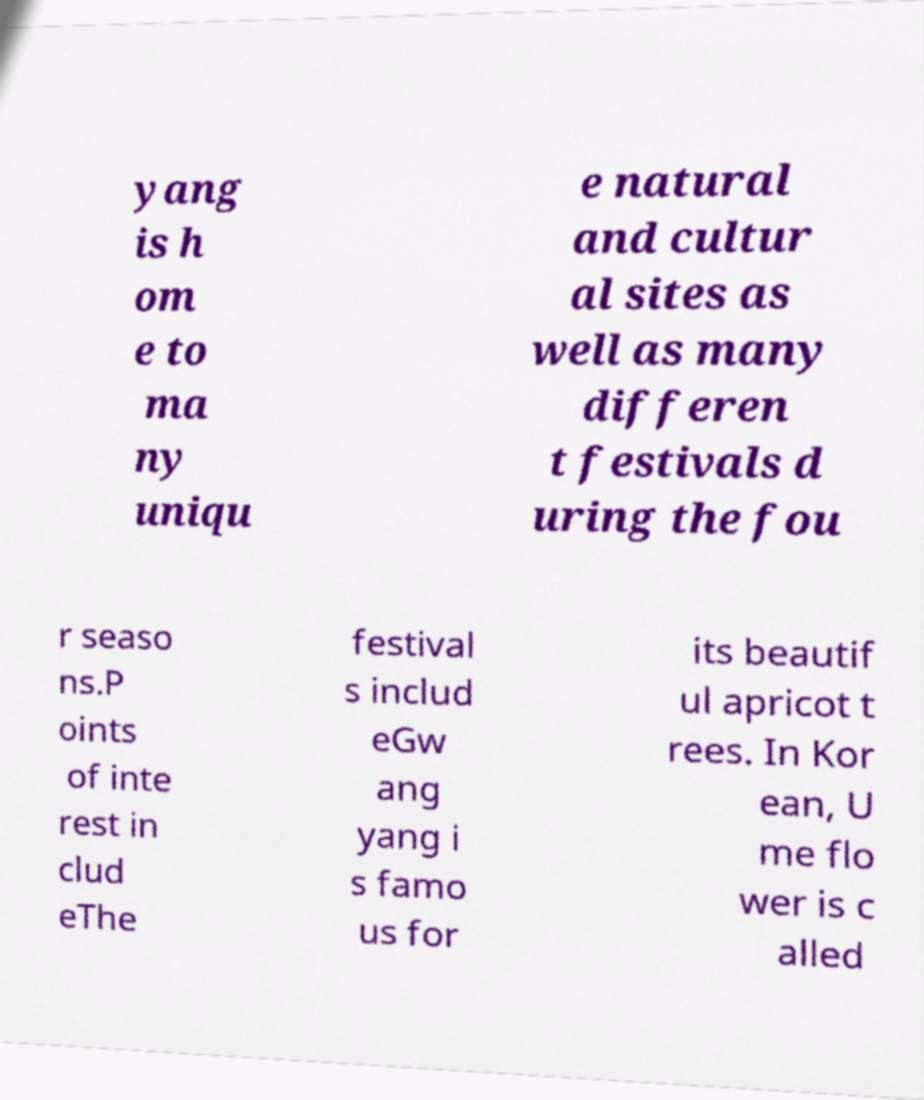Please read and relay the text visible in this image. What does it say? yang is h om e to ma ny uniqu e natural and cultur al sites as well as many differen t festivals d uring the fou r seaso ns.P oints of inte rest in clud eThe festival s includ eGw ang yang i s famo us for its beautif ul apricot t rees. In Kor ean, U me flo wer is c alled 